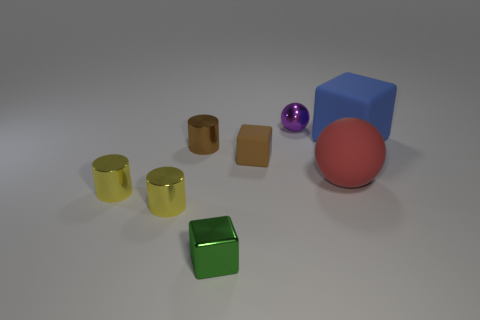Subtract all matte cubes. How many cubes are left? 1 Subtract all brown cubes. How many cubes are left? 2 Add 1 big purple metal blocks. How many objects exist? 9 Subtract all balls. How many objects are left? 6 Subtract 1 balls. How many balls are left? 1 Subtract all cyan blocks. How many green cylinders are left? 0 Subtract all tiny brown shiny cylinders. Subtract all red things. How many objects are left? 6 Add 4 tiny green metallic blocks. How many tiny green metallic blocks are left? 5 Add 1 purple metal blocks. How many purple metal blocks exist? 1 Subtract 1 brown blocks. How many objects are left? 7 